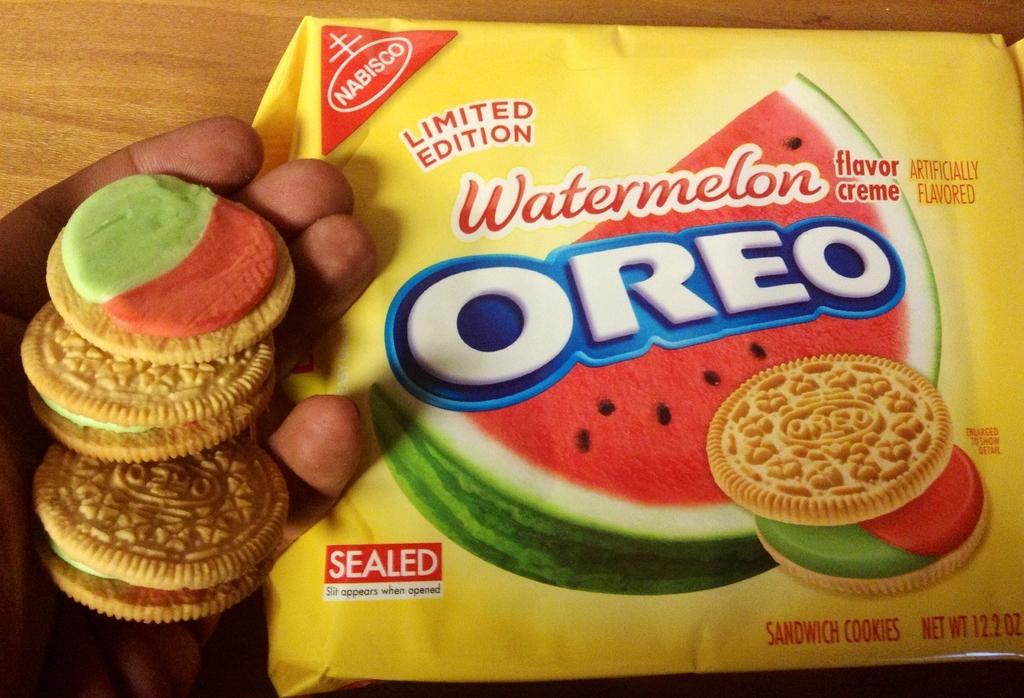What is the person's hand holding in the image? The person's hand is holding cream biscuits in the image. Where are the cream biscuits located in the image? The cream biscuits are in the person's hand. What else can be seen related to the cream biscuits in the image? There is a biscuit packet on a table in the image. What type of sheet is covering the person in the image? There is no person or sheet present in the image; it only shows a person's hand holding cream biscuits and a biscuit packet on a table. 